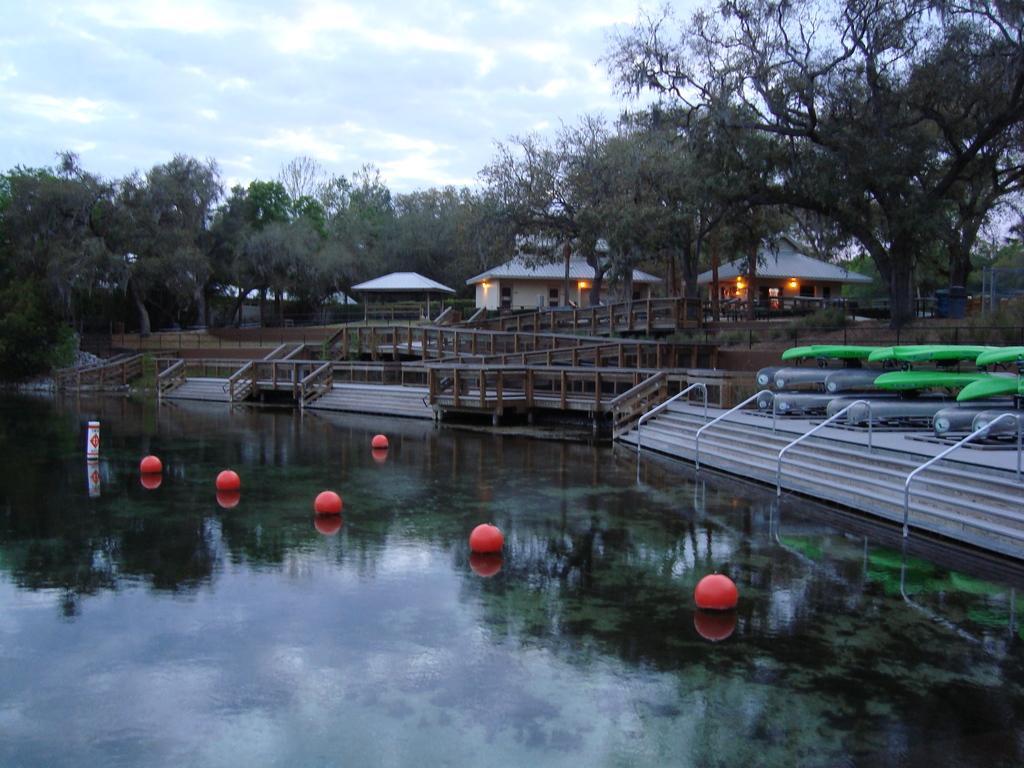In one or two sentences, can you explain what this image depicts? This picture is clicked outside. In the foreground we can see an object and the ball like objects are in the water body. In the center we can see the staircase, metal rods, a bridge like object, a gazebo and the houses and we can see the lights. On the right there are some objects placed on the ground. In the background we can see the sky with the clouds and we can see the trees, houses and some other objects. 